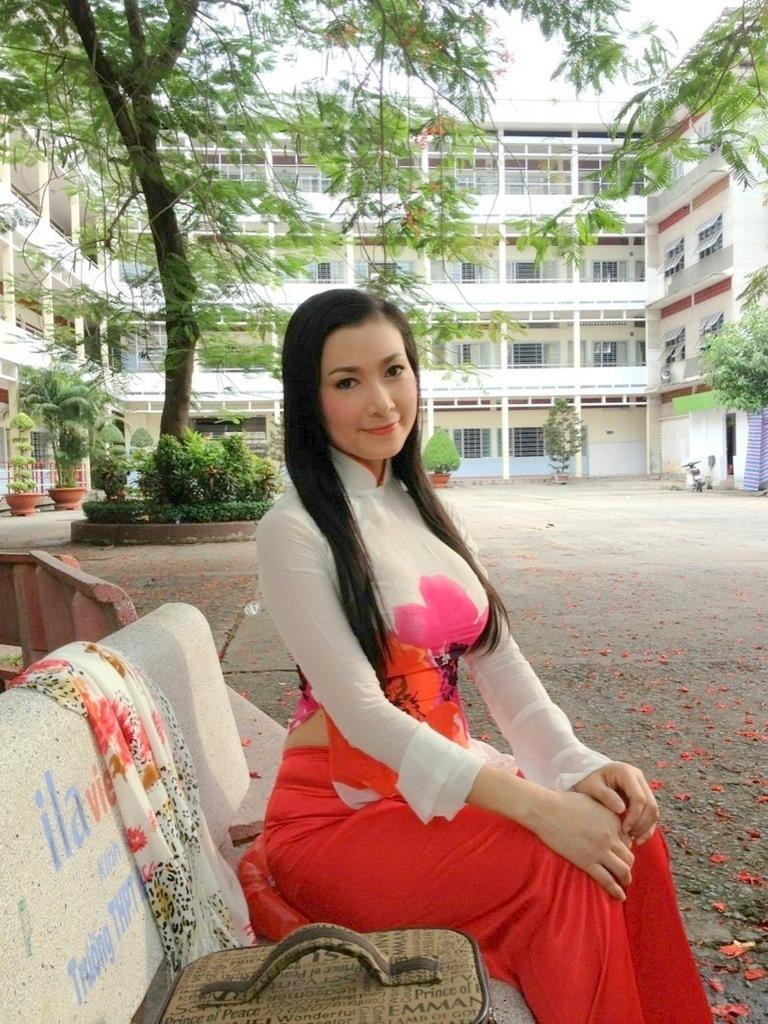Could you give a brief overview of what you see in this image? In this picture we can see a bag, cloth and a woman sitting on a bench. In the background we can see the ground, plants, pots, trees, buildings with windows and the sky. 